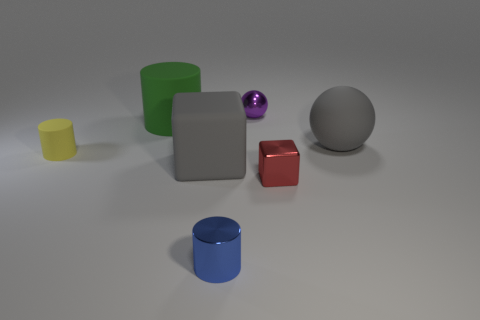There is a cube right of the big object in front of the large matte ball; what is its size?
Ensure brevity in your answer.  Small. How many objects are behind the gray cube and in front of the gray block?
Provide a short and direct response. 0. There is a tiny shiny sphere right of the green matte thing that is on the left side of the small red metallic thing; is there a big gray rubber sphere that is on the right side of it?
Provide a short and direct response. Yes. What shape is the blue thing that is the same size as the yellow matte cylinder?
Your response must be concise. Cylinder. Is there a large object of the same color as the matte block?
Provide a short and direct response. Yes. Is the shape of the tiny blue metallic object the same as the purple metal object?
Ensure brevity in your answer.  No. What number of big things are either gray blocks or gray matte balls?
Keep it short and to the point. 2. What is the color of the block that is made of the same material as the large ball?
Make the answer very short. Gray. How many other things are made of the same material as the purple object?
Your response must be concise. 2. There is a matte thing left of the green thing; is it the same size as the block behind the tiny red block?
Offer a very short reply. No. 